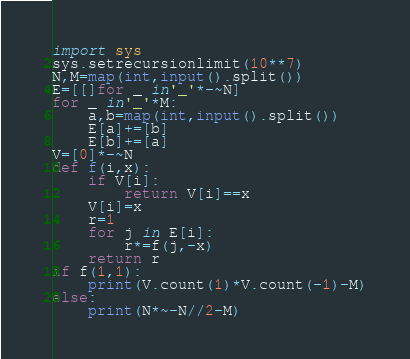Convert code to text. <code><loc_0><loc_0><loc_500><loc_500><_Python_>import sys
sys.setrecursionlimit(10**7)
N,M=map(int,input().split())
E=[[]for _ in'_'*-~N]
for _ in'_'*M:
	a,b=map(int,input().split())
	E[a]+=[b]
	E[b]+=[a]
V=[0]*-~N
def f(i,x):
	if V[i]:
		return V[i]==x
	V[i]=x
	r=1
	for j in E[i]:
		r*=f(j,-x)
	return r
if f(1,1):
	print(V.count(1)*V.count(-1)-M)
else:
	print(N*~-N//2-M)</code> 